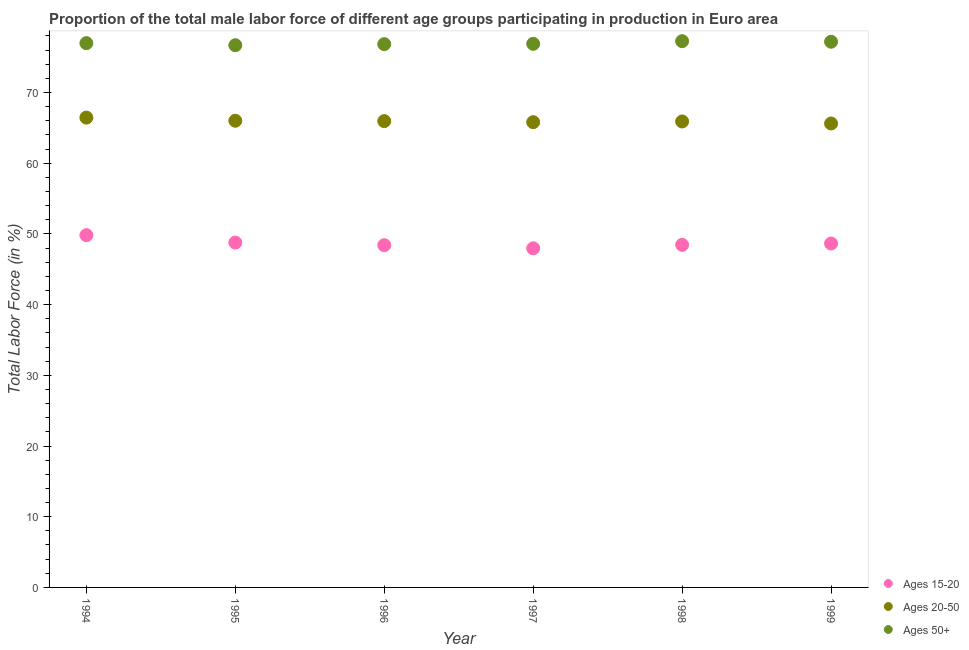How many different coloured dotlines are there?
Ensure brevity in your answer.  3. Is the number of dotlines equal to the number of legend labels?
Ensure brevity in your answer.  Yes. What is the percentage of male labor force above age 50 in 1999?
Your answer should be compact. 77.17. Across all years, what is the maximum percentage of male labor force within the age group 20-50?
Your response must be concise. 66.44. Across all years, what is the minimum percentage of male labor force above age 50?
Provide a short and direct response. 76.68. In which year was the percentage of male labor force above age 50 maximum?
Keep it short and to the point. 1998. In which year was the percentage of male labor force within the age group 15-20 minimum?
Offer a terse response. 1997. What is the total percentage of male labor force within the age group 15-20 in the graph?
Keep it short and to the point. 292.03. What is the difference between the percentage of male labor force within the age group 15-20 in 1996 and that in 1998?
Provide a short and direct response. -0.05. What is the difference between the percentage of male labor force above age 50 in 1996 and the percentage of male labor force within the age group 15-20 in 1998?
Offer a terse response. 28.38. What is the average percentage of male labor force within the age group 15-20 per year?
Provide a short and direct response. 48.67. In the year 1994, what is the difference between the percentage of male labor force within the age group 15-20 and percentage of male labor force within the age group 20-50?
Ensure brevity in your answer.  -16.62. What is the ratio of the percentage of male labor force within the age group 15-20 in 1995 to that in 1996?
Ensure brevity in your answer.  1.01. Is the percentage of male labor force above age 50 in 1995 less than that in 1996?
Provide a succinct answer. Yes. Is the difference between the percentage of male labor force within the age group 15-20 in 1994 and 1996 greater than the difference between the percentage of male labor force above age 50 in 1994 and 1996?
Keep it short and to the point. Yes. What is the difference between the highest and the second highest percentage of male labor force above age 50?
Make the answer very short. 0.08. What is the difference between the highest and the lowest percentage of male labor force within the age group 15-20?
Your response must be concise. 1.86. In how many years, is the percentage of male labor force within the age group 15-20 greater than the average percentage of male labor force within the age group 15-20 taken over all years?
Your answer should be compact. 2. Is the percentage of male labor force within the age group 15-20 strictly greater than the percentage of male labor force within the age group 20-50 over the years?
Your answer should be compact. No. How many dotlines are there?
Offer a terse response. 3. What is the difference between two consecutive major ticks on the Y-axis?
Provide a short and direct response. 10. Are the values on the major ticks of Y-axis written in scientific E-notation?
Keep it short and to the point. No. Does the graph contain any zero values?
Offer a terse response. No. Does the graph contain grids?
Give a very brief answer. No. How many legend labels are there?
Offer a very short reply. 3. How are the legend labels stacked?
Provide a succinct answer. Vertical. What is the title of the graph?
Make the answer very short. Proportion of the total male labor force of different age groups participating in production in Euro area. Does "Consumption Tax" appear as one of the legend labels in the graph?
Provide a succinct answer. No. What is the label or title of the Y-axis?
Ensure brevity in your answer.  Total Labor Force (in %). What is the Total Labor Force (in %) in Ages 15-20 in 1994?
Your response must be concise. 49.82. What is the Total Labor Force (in %) in Ages 20-50 in 1994?
Provide a short and direct response. 66.44. What is the Total Labor Force (in %) in Ages 50+ in 1994?
Give a very brief answer. 76.97. What is the Total Labor Force (in %) in Ages 15-20 in 1995?
Give a very brief answer. 48.77. What is the Total Labor Force (in %) in Ages 20-50 in 1995?
Your answer should be compact. 66. What is the Total Labor Force (in %) in Ages 50+ in 1995?
Offer a terse response. 76.68. What is the Total Labor Force (in %) in Ages 15-20 in 1996?
Ensure brevity in your answer.  48.4. What is the Total Labor Force (in %) in Ages 20-50 in 1996?
Your answer should be compact. 65.95. What is the Total Labor Force (in %) in Ages 50+ in 1996?
Keep it short and to the point. 76.83. What is the Total Labor Force (in %) of Ages 15-20 in 1997?
Your answer should be compact. 47.96. What is the Total Labor Force (in %) in Ages 20-50 in 1997?
Offer a very short reply. 65.79. What is the Total Labor Force (in %) of Ages 50+ in 1997?
Give a very brief answer. 76.88. What is the Total Labor Force (in %) in Ages 15-20 in 1998?
Your answer should be very brief. 48.45. What is the Total Labor Force (in %) in Ages 20-50 in 1998?
Keep it short and to the point. 65.89. What is the Total Labor Force (in %) of Ages 50+ in 1998?
Keep it short and to the point. 77.25. What is the Total Labor Force (in %) in Ages 15-20 in 1999?
Ensure brevity in your answer.  48.64. What is the Total Labor Force (in %) in Ages 20-50 in 1999?
Offer a very short reply. 65.61. What is the Total Labor Force (in %) in Ages 50+ in 1999?
Offer a terse response. 77.17. Across all years, what is the maximum Total Labor Force (in %) in Ages 15-20?
Make the answer very short. 49.82. Across all years, what is the maximum Total Labor Force (in %) of Ages 20-50?
Your answer should be compact. 66.44. Across all years, what is the maximum Total Labor Force (in %) in Ages 50+?
Provide a succinct answer. 77.25. Across all years, what is the minimum Total Labor Force (in %) of Ages 15-20?
Keep it short and to the point. 47.96. Across all years, what is the minimum Total Labor Force (in %) of Ages 20-50?
Give a very brief answer. 65.61. Across all years, what is the minimum Total Labor Force (in %) in Ages 50+?
Your answer should be compact. 76.68. What is the total Total Labor Force (in %) in Ages 15-20 in the graph?
Keep it short and to the point. 292.03. What is the total Total Labor Force (in %) in Ages 20-50 in the graph?
Keep it short and to the point. 395.68. What is the total Total Labor Force (in %) in Ages 50+ in the graph?
Your response must be concise. 461.78. What is the difference between the Total Labor Force (in %) of Ages 15-20 in 1994 and that in 1995?
Provide a succinct answer. 1.05. What is the difference between the Total Labor Force (in %) in Ages 20-50 in 1994 and that in 1995?
Your answer should be compact. 0.44. What is the difference between the Total Labor Force (in %) of Ages 50+ in 1994 and that in 1995?
Keep it short and to the point. 0.29. What is the difference between the Total Labor Force (in %) in Ages 15-20 in 1994 and that in 1996?
Your answer should be very brief. 1.42. What is the difference between the Total Labor Force (in %) in Ages 20-50 in 1994 and that in 1996?
Ensure brevity in your answer.  0.49. What is the difference between the Total Labor Force (in %) of Ages 50+ in 1994 and that in 1996?
Provide a short and direct response. 0.14. What is the difference between the Total Labor Force (in %) in Ages 15-20 in 1994 and that in 1997?
Your answer should be compact. 1.86. What is the difference between the Total Labor Force (in %) in Ages 20-50 in 1994 and that in 1997?
Your answer should be compact. 0.65. What is the difference between the Total Labor Force (in %) in Ages 50+ in 1994 and that in 1997?
Give a very brief answer. 0.09. What is the difference between the Total Labor Force (in %) in Ages 15-20 in 1994 and that in 1998?
Your answer should be very brief. 1.37. What is the difference between the Total Labor Force (in %) in Ages 20-50 in 1994 and that in 1998?
Keep it short and to the point. 0.55. What is the difference between the Total Labor Force (in %) of Ages 50+ in 1994 and that in 1998?
Provide a short and direct response. -0.28. What is the difference between the Total Labor Force (in %) in Ages 15-20 in 1994 and that in 1999?
Ensure brevity in your answer.  1.18. What is the difference between the Total Labor Force (in %) of Ages 20-50 in 1994 and that in 1999?
Provide a succinct answer. 0.83. What is the difference between the Total Labor Force (in %) of Ages 50+ in 1994 and that in 1999?
Ensure brevity in your answer.  -0.2. What is the difference between the Total Labor Force (in %) of Ages 15-20 in 1995 and that in 1996?
Provide a succinct answer. 0.37. What is the difference between the Total Labor Force (in %) of Ages 20-50 in 1995 and that in 1996?
Make the answer very short. 0.05. What is the difference between the Total Labor Force (in %) in Ages 50+ in 1995 and that in 1996?
Ensure brevity in your answer.  -0.15. What is the difference between the Total Labor Force (in %) of Ages 15-20 in 1995 and that in 1997?
Keep it short and to the point. 0.81. What is the difference between the Total Labor Force (in %) of Ages 20-50 in 1995 and that in 1997?
Give a very brief answer. 0.2. What is the difference between the Total Labor Force (in %) of Ages 50+ in 1995 and that in 1997?
Your answer should be very brief. -0.2. What is the difference between the Total Labor Force (in %) of Ages 15-20 in 1995 and that in 1998?
Make the answer very short. 0.32. What is the difference between the Total Labor Force (in %) of Ages 20-50 in 1995 and that in 1998?
Ensure brevity in your answer.  0.1. What is the difference between the Total Labor Force (in %) of Ages 50+ in 1995 and that in 1998?
Provide a short and direct response. -0.57. What is the difference between the Total Labor Force (in %) of Ages 15-20 in 1995 and that in 1999?
Make the answer very short. 0.13. What is the difference between the Total Labor Force (in %) of Ages 20-50 in 1995 and that in 1999?
Offer a terse response. 0.39. What is the difference between the Total Labor Force (in %) in Ages 50+ in 1995 and that in 1999?
Make the answer very short. -0.49. What is the difference between the Total Labor Force (in %) of Ages 15-20 in 1996 and that in 1997?
Make the answer very short. 0.44. What is the difference between the Total Labor Force (in %) of Ages 20-50 in 1996 and that in 1997?
Provide a short and direct response. 0.15. What is the difference between the Total Labor Force (in %) in Ages 50+ in 1996 and that in 1997?
Give a very brief answer. -0.05. What is the difference between the Total Labor Force (in %) in Ages 15-20 in 1996 and that in 1998?
Give a very brief answer. -0.05. What is the difference between the Total Labor Force (in %) in Ages 20-50 in 1996 and that in 1998?
Offer a terse response. 0.05. What is the difference between the Total Labor Force (in %) of Ages 50+ in 1996 and that in 1998?
Make the answer very short. -0.42. What is the difference between the Total Labor Force (in %) in Ages 15-20 in 1996 and that in 1999?
Ensure brevity in your answer.  -0.24. What is the difference between the Total Labor Force (in %) of Ages 20-50 in 1996 and that in 1999?
Offer a terse response. 0.34. What is the difference between the Total Labor Force (in %) in Ages 50+ in 1996 and that in 1999?
Your answer should be very brief. -0.34. What is the difference between the Total Labor Force (in %) of Ages 15-20 in 1997 and that in 1998?
Offer a terse response. -0.49. What is the difference between the Total Labor Force (in %) of Ages 20-50 in 1997 and that in 1998?
Offer a very short reply. -0.1. What is the difference between the Total Labor Force (in %) in Ages 50+ in 1997 and that in 1998?
Provide a succinct answer. -0.37. What is the difference between the Total Labor Force (in %) in Ages 15-20 in 1997 and that in 1999?
Offer a very short reply. -0.68. What is the difference between the Total Labor Force (in %) of Ages 20-50 in 1997 and that in 1999?
Your answer should be compact. 0.19. What is the difference between the Total Labor Force (in %) in Ages 50+ in 1997 and that in 1999?
Provide a succinct answer. -0.3. What is the difference between the Total Labor Force (in %) in Ages 15-20 in 1998 and that in 1999?
Offer a very short reply. -0.19. What is the difference between the Total Labor Force (in %) in Ages 20-50 in 1998 and that in 1999?
Make the answer very short. 0.29. What is the difference between the Total Labor Force (in %) in Ages 50+ in 1998 and that in 1999?
Your response must be concise. 0.08. What is the difference between the Total Labor Force (in %) of Ages 15-20 in 1994 and the Total Labor Force (in %) of Ages 20-50 in 1995?
Provide a succinct answer. -16.18. What is the difference between the Total Labor Force (in %) in Ages 15-20 in 1994 and the Total Labor Force (in %) in Ages 50+ in 1995?
Keep it short and to the point. -26.86. What is the difference between the Total Labor Force (in %) in Ages 20-50 in 1994 and the Total Labor Force (in %) in Ages 50+ in 1995?
Offer a terse response. -10.24. What is the difference between the Total Labor Force (in %) of Ages 15-20 in 1994 and the Total Labor Force (in %) of Ages 20-50 in 1996?
Your answer should be very brief. -16.13. What is the difference between the Total Labor Force (in %) of Ages 15-20 in 1994 and the Total Labor Force (in %) of Ages 50+ in 1996?
Your answer should be very brief. -27.02. What is the difference between the Total Labor Force (in %) of Ages 20-50 in 1994 and the Total Labor Force (in %) of Ages 50+ in 1996?
Ensure brevity in your answer.  -10.39. What is the difference between the Total Labor Force (in %) in Ages 15-20 in 1994 and the Total Labor Force (in %) in Ages 20-50 in 1997?
Offer a very short reply. -15.98. What is the difference between the Total Labor Force (in %) of Ages 15-20 in 1994 and the Total Labor Force (in %) of Ages 50+ in 1997?
Provide a succinct answer. -27.06. What is the difference between the Total Labor Force (in %) of Ages 20-50 in 1994 and the Total Labor Force (in %) of Ages 50+ in 1997?
Ensure brevity in your answer.  -10.44. What is the difference between the Total Labor Force (in %) in Ages 15-20 in 1994 and the Total Labor Force (in %) in Ages 20-50 in 1998?
Provide a short and direct response. -16.08. What is the difference between the Total Labor Force (in %) in Ages 15-20 in 1994 and the Total Labor Force (in %) in Ages 50+ in 1998?
Your answer should be compact. -27.43. What is the difference between the Total Labor Force (in %) of Ages 20-50 in 1994 and the Total Labor Force (in %) of Ages 50+ in 1998?
Your response must be concise. -10.81. What is the difference between the Total Labor Force (in %) in Ages 15-20 in 1994 and the Total Labor Force (in %) in Ages 20-50 in 1999?
Offer a terse response. -15.79. What is the difference between the Total Labor Force (in %) of Ages 15-20 in 1994 and the Total Labor Force (in %) of Ages 50+ in 1999?
Offer a very short reply. -27.36. What is the difference between the Total Labor Force (in %) of Ages 20-50 in 1994 and the Total Labor Force (in %) of Ages 50+ in 1999?
Your response must be concise. -10.73. What is the difference between the Total Labor Force (in %) in Ages 15-20 in 1995 and the Total Labor Force (in %) in Ages 20-50 in 1996?
Your response must be concise. -17.18. What is the difference between the Total Labor Force (in %) in Ages 15-20 in 1995 and the Total Labor Force (in %) in Ages 50+ in 1996?
Your response must be concise. -28.06. What is the difference between the Total Labor Force (in %) in Ages 20-50 in 1995 and the Total Labor Force (in %) in Ages 50+ in 1996?
Ensure brevity in your answer.  -10.83. What is the difference between the Total Labor Force (in %) of Ages 15-20 in 1995 and the Total Labor Force (in %) of Ages 20-50 in 1997?
Give a very brief answer. -17.03. What is the difference between the Total Labor Force (in %) of Ages 15-20 in 1995 and the Total Labor Force (in %) of Ages 50+ in 1997?
Give a very brief answer. -28.11. What is the difference between the Total Labor Force (in %) of Ages 20-50 in 1995 and the Total Labor Force (in %) of Ages 50+ in 1997?
Make the answer very short. -10.88. What is the difference between the Total Labor Force (in %) of Ages 15-20 in 1995 and the Total Labor Force (in %) of Ages 20-50 in 1998?
Offer a terse response. -17.13. What is the difference between the Total Labor Force (in %) of Ages 15-20 in 1995 and the Total Labor Force (in %) of Ages 50+ in 1998?
Keep it short and to the point. -28.48. What is the difference between the Total Labor Force (in %) in Ages 20-50 in 1995 and the Total Labor Force (in %) in Ages 50+ in 1998?
Offer a terse response. -11.25. What is the difference between the Total Labor Force (in %) of Ages 15-20 in 1995 and the Total Labor Force (in %) of Ages 20-50 in 1999?
Make the answer very short. -16.84. What is the difference between the Total Labor Force (in %) in Ages 15-20 in 1995 and the Total Labor Force (in %) in Ages 50+ in 1999?
Provide a succinct answer. -28.4. What is the difference between the Total Labor Force (in %) in Ages 20-50 in 1995 and the Total Labor Force (in %) in Ages 50+ in 1999?
Keep it short and to the point. -11.17. What is the difference between the Total Labor Force (in %) in Ages 15-20 in 1996 and the Total Labor Force (in %) in Ages 20-50 in 1997?
Ensure brevity in your answer.  -17.39. What is the difference between the Total Labor Force (in %) in Ages 15-20 in 1996 and the Total Labor Force (in %) in Ages 50+ in 1997?
Keep it short and to the point. -28.48. What is the difference between the Total Labor Force (in %) of Ages 20-50 in 1996 and the Total Labor Force (in %) of Ages 50+ in 1997?
Make the answer very short. -10.93. What is the difference between the Total Labor Force (in %) in Ages 15-20 in 1996 and the Total Labor Force (in %) in Ages 20-50 in 1998?
Give a very brief answer. -17.49. What is the difference between the Total Labor Force (in %) in Ages 15-20 in 1996 and the Total Labor Force (in %) in Ages 50+ in 1998?
Offer a terse response. -28.85. What is the difference between the Total Labor Force (in %) of Ages 20-50 in 1996 and the Total Labor Force (in %) of Ages 50+ in 1998?
Your response must be concise. -11.3. What is the difference between the Total Labor Force (in %) of Ages 15-20 in 1996 and the Total Labor Force (in %) of Ages 20-50 in 1999?
Your answer should be compact. -17.21. What is the difference between the Total Labor Force (in %) of Ages 15-20 in 1996 and the Total Labor Force (in %) of Ages 50+ in 1999?
Provide a short and direct response. -28.77. What is the difference between the Total Labor Force (in %) in Ages 20-50 in 1996 and the Total Labor Force (in %) in Ages 50+ in 1999?
Your response must be concise. -11.23. What is the difference between the Total Labor Force (in %) in Ages 15-20 in 1997 and the Total Labor Force (in %) in Ages 20-50 in 1998?
Offer a terse response. -17.94. What is the difference between the Total Labor Force (in %) of Ages 15-20 in 1997 and the Total Labor Force (in %) of Ages 50+ in 1998?
Offer a terse response. -29.29. What is the difference between the Total Labor Force (in %) of Ages 20-50 in 1997 and the Total Labor Force (in %) of Ages 50+ in 1998?
Ensure brevity in your answer.  -11.46. What is the difference between the Total Labor Force (in %) in Ages 15-20 in 1997 and the Total Labor Force (in %) in Ages 20-50 in 1999?
Make the answer very short. -17.65. What is the difference between the Total Labor Force (in %) of Ages 15-20 in 1997 and the Total Labor Force (in %) of Ages 50+ in 1999?
Give a very brief answer. -29.21. What is the difference between the Total Labor Force (in %) of Ages 20-50 in 1997 and the Total Labor Force (in %) of Ages 50+ in 1999?
Provide a succinct answer. -11.38. What is the difference between the Total Labor Force (in %) of Ages 15-20 in 1998 and the Total Labor Force (in %) of Ages 20-50 in 1999?
Provide a succinct answer. -17.16. What is the difference between the Total Labor Force (in %) of Ages 15-20 in 1998 and the Total Labor Force (in %) of Ages 50+ in 1999?
Ensure brevity in your answer.  -28.72. What is the difference between the Total Labor Force (in %) of Ages 20-50 in 1998 and the Total Labor Force (in %) of Ages 50+ in 1999?
Keep it short and to the point. -11.28. What is the average Total Labor Force (in %) of Ages 15-20 per year?
Offer a very short reply. 48.67. What is the average Total Labor Force (in %) in Ages 20-50 per year?
Your answer should be very brief. 65.95. What is the average Total Labor Force (in %) of Ages 50+ per year?
Offer a terse response. 76.96. In the year 1994, what is the difference between the Total Labor Force (in %) of Ages 15-20 and Total Labor Force (in %) of Ages 20-50?
Offer a terse response. -16.62. In the year 1994, what is the difference between the Total Labor Force (in %) in Ages 15-20 and Total Labor Force (in %) in Ages 50+?
Offer a very short reply. -27.15. In the year 1994, what is the difference between the Total Labor Force (in %) in Ages 20-50 and Total Labor Force (in %) in Ages 50+?
Keep it short and to the point. -10.53. In the year 1995, what is the difference between the Total Labor Force (in %) of Ages 15-20 and Total Labor Force (in %) of Ages 20-50?
Your response must be concise. -17.23. In the year 1995, what is the difference between the Total Labor Force (in %) in Ages 15-20 and Total Labor Force (in %) in Ages 50+?
Your answer should be very brief. -27.91. In the year 1995, what is the difference between the Total Labor Force (in %) in Ages 20-50 and Total Labor Force (in %) in Ages 50+?
Ensure brevity in your answer.  -10.68. In the year 1996, what is the difference between the Total Labor Force (in %) of Ages 15-20 and Total Labor Force (in %) of Ages 20-50?
Your answer should be compact. -17.55. In the year 1996, what is the difference between the Total Labor Force (in %) of Ages 15-20 and Total Labor Force (in %) of Ages 50+?
Offer a very short reply. -28.43. In the year 1996, what is the difference between the Total Labor Force (in %) of Ages 20-50 and Total Labor Force (in %) of Ages 50+?
Make the answer very short. -10.89. In the year 1997, what is the difference between the Total Labor Force (in %) in Ages 15-20 and Total Labor Force (in %) in Ages 20-50?
Give a very brief answer. -17.84. In the year 1997, what is the difference between the Total Labor Force (in %) in Ages 15-20 and Total Labor Force (in %) in Ages 50+?
Offer a very short reply. -28.92. In the year 1997, what is the difference between the Total Labor Force (in %) in Ages 20-50 and Total Labor Force (in %) in Ages 50+?
Give a very brief answer. -11.08. In the year 1998, what is the difference between the Total Labor Force (in %) in Ages 15-20 and Total Labor Force (in %) in Ages 20-50?
Make the answer very short. -17.45. In the year 1998, what is the difference between the Total Labor Force (in %) of Ages 15-20 and Total Labor Force (in %) of Ages 50+?
Give a very brief answer. -28.8. In the year 1998, what is the difference between the Total Labor Force (in %) in Ages 20-50 and Total Labor Force (in %) in Ages 50+?
Provide a succinct answer. -11.35. In the year 1999, what is the difference between the Total Labor Force (in %) of Ages 15-20 and Total Labor Force (in %) of Ages 20-50?
Make the answer very short. -16.97. In the year 1999, what is the difference between the Total Labor Force (in %) in Ages 15-20 and Total Labor Force (in %) in Ages 50+?
Provide a short and direct response. -28.54. In the year 1999, what is the difference between the Total Labor Force (in %) in Ages 20-50 and Total Labor Force (in %) in Ages 50+?
Offer a terse response. -11.56. What is the ratio of the Total Labor Force (in %) in Ages 15-20 in 1994 to that in 1995?
Give a very brief answer. 1.02. What is the ratio of the Total Labor Force (in %) in Ages 20-50 in 1994 to that in 1995?
Your response must be concise. 1.01. What is the ratio of the Total Labor Force (in %) of Ages 15-20 in 1994 to that in 1996?
Ensure brevity in your answer.  1.03. What is the ratio of the Total Labor Force (in %) in Ages 20-50 in 1994 to that in 1996?
Your answer should be compact. 1.01. What is the ratio of the Total Labor Force (in %) in Ages 50+ in 1994 to that in 1996?
Your answer should be very brief. 1. What is the ratio of the Total Labor Force (in %) in Ages 15-20 in 1994 to that in 1997?
Your answer should be very brief. 1.04. What is the ratio of the Total Labor Force (in %) in Ages 20-50 in 1994 to that in 1997?
Your answer should be very brief. 1.01. What is the ratio of the Total Labor Force (in %) of Ages 50+ in 1994 to that in 1997?
Your answer should be compact. 1. What is the ratio of the Total Labor Force (in %) in Ages 15-20 in 1994 to that in 1998?
Give a very brief answer. 1.03. What is the ratio of the Total Labor Force (in %) in Ages 20-50 in 1994 to that in 1998?
Ensure brevity in your answer.  1.01. What is the ratio of the Total Labor Force (in %) in Ages 15-20 in 1994 to that in 1999?
Your answer should be compact. 1.02. What is the ratio of the Total Labor Force (in %) of Ages 20-50 in 1994 to that in 1999?
Provide a short and direct response. 1.01. What is the ratio of the Total Labor Force (in %) of Ages 50+ in 1994 to that in 1999?
Your response must be concise. 1. What is the ratio of the Total Labor Force (in %) in Ages 15-20 in 1995 to that in 1996?
Your response must be concise. 1.01. What is the ratio of the Total Labor Force (in %) in Ages 15-20 in 1995 to that in 1997?
Provide a succinct answer. 1.02. What is the ratio of the Total Labor Force (in %) in Ages 20-50 in 1995 to that in 1997?
Provide a succinct answer. 1. What is the ratio of the Total Labor Force (in %) in Ages 15-20 in 1995 to that in 1998?
Your response must be concise. 1.01. What is the ratio of the Total Labor Force (in %) in Ages 20-50 in 1995 to that in 1998?
Keep it short and to the point. 1. What is the ratio of the Total Labor Force (in %) in Ages 50+ in 1995 to that in 1998?
Your response must be concise. 0.99. What is the ratio of the Total Labor Force (in %) of Ages 20-50 in 1995 to that in 1999?
Provide a short and direct response. 1.01. What is the ratio of the Total Labor Force (in %) in Ages 50+ in 1995 to that in 1999?
Your response must be concise. 0.99. What is the ratio of the Total Labor Force (in %) in Ages 15-20 in 1996 to that in 1997?
Ensure brevity in your answer.  1.01. What is the ratio of the Total Labor Force (in %) of Ages 15-20 in 1996 to that in 1998?
Your answer should be compact. 1. What is the ratio of the Total Labor Force (in %) in Ages 50+ in 1996 to that in 1998?
Keep it short and to the point. 0.99. What is the ratio of the Total Labor Force (in %) in Ages 50+ in 1996 to that in 1999?
Provide a short and direct response. 1. What is the ratio of the Total Labor Force (in %) of Ages 15-20 in 1997 to that in 1998?
Make the answer very short. 0.99. What is the ratio of the Total Labor Force (in %) in Ages 20-50 in 1997 to that in 1998?
Your response must be concise. 1. What is the ratio of the Total Labor Force (in %) of Ages 15-20 in 1997 to that in 1999?
Provide a short and direct response. 0.99. What is the ratio of the Total Labor Force (in %) in Ages 20-50 in 1997 to that in 1999?
Provide a succinct answer. 1. What is the ratio of the Total Labor Force (in %) in Ages 15-20 in 1998 to that in 1999?
Provide a succinct answer. 1. What is the ratio of the Total Labor Force (in %) in Ages 50+ in 1998 to that in 1999?
Provide a short and direct response. 1. What is the difference between the highest and the second highest Total Labor Force (in %) of Ages 15-20?
Your answer should be very brief. 1.05. What is the difference between the highest and the second highest Total Labor Force (in %) of Ages 20-50?
Your response must be concise. 0.44. What is the difference between the highest and the second highest Total Labor Force (in %) of Ages 50+?
Your answer should be compact. 0.08. What is the difference between the highest and the lowest Total Labor Force (in %) in Ages 15-20?
Offer a terse response. 1.86. What is the difference between the highest and the lowest Total Labor Force (in %) in Ages 20-50?
Your answer should be compact. 0.83. What is the difference between the highest and the lowest Total Labor Force (in %) in Ages 50+?
Offer a very short reply. 0.57. 